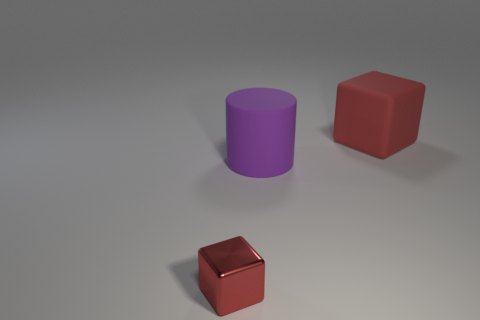Are there any other things that have the same material as the small red thing?
Keep it short and to the point. No. What number of other red objects are the same shape as the tiny red thing?
Offer a terse response. 1. There is a red block on the right side of the tiny red block; is it the same size as the matte object that is to the left of the large cube?
Make the answer very short. Yes. The big object left of the red block behind the small red thing is what shape?
Offer a very short reply. Cylinder. Is the number of small shiny cubes that are on the right side of the cylinder the same as the number of red metallic things?
Ensure brevity in your answer.  No. There is a big thing behind the large matte thing that is in front of the red thing that is behind the small red metal thing; what is its material?
Give a very brief answer. Rubber. Are there any blue rubber cylinders that have the same size as the purple thing?
Ensure brevity in your answer.  No. The large red matte thing is what shape?
Make the answer very short. Cube. What number of spheres are either small cyan metal objects or metallic things?
Your answer should be very brief. 0. Are there the same number of large cubes that are right of the big red thing and purple cylinders right of the large purple rubber thing?
Ensure brevity in your answer.  Yes. 